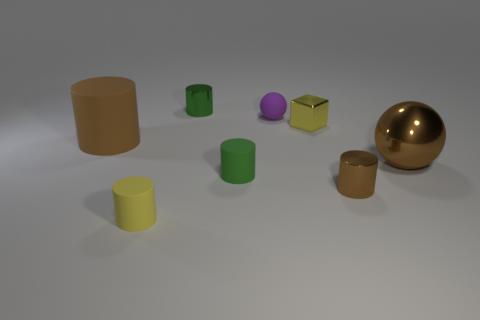What material is the cube?
Offer a very short reply. Metal. What is the shape of the tiny green thing that is the same material as the small yellow cube?
Provide a succinct answer. Cylinder. What is the size of the sphere in front of the brown thing that is to the left of the yellow matte cylinder?
Provide a short and direct response. Large. There is a big object that is to the right of the big rubber cylinder; what color is it?
Ensure brevity in your answer.  Brown. Are there any other things that have the same shape as the small purple thing?
Your answer should be very brief. Yes. Are there fewer small metal objects that are to the right of the tiny brown object than small cylinders that are to the right of the small green shiny cylinder?
Your answer should be compact. Yes. The metal block is what color?
Keep it short and to the point. Yellow. There is a tiny rubber object that is behind the small green rubber cylinder; are there any big balls behind it?
Keep it short and to the point. No. What number of metallic cylinders are the same size as the purple thing?
Offer a terse response. 2. What number of purple objects are in front of the green cylinder behind the tiny matte thing that is behind the tiny block?
Make the answer very short. 1. 